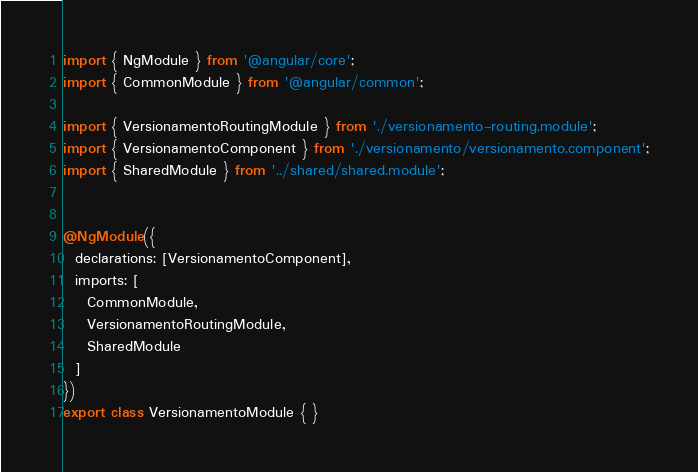<code> <loc_0><loc_0><loc_500><loc_500><_TypeScript_>import { NgModule } from '@angular/core';
import { CommonModule } from '@angular/common';

import { VersionamentoRoutingModule } from './versionamento-routing.module';
import { VersionamentoComponent } from './versionamento/versionamento.component';
import { SharedModule } from '../shared/shared.module';


@NgModule({
  declarations: [VersionamentoComponent],
  imports: [
    CommonModule,
    VersionamentoRoutingModule,
    SharedModule
  ]
})
export class VersionamentoModule { }
</code> 